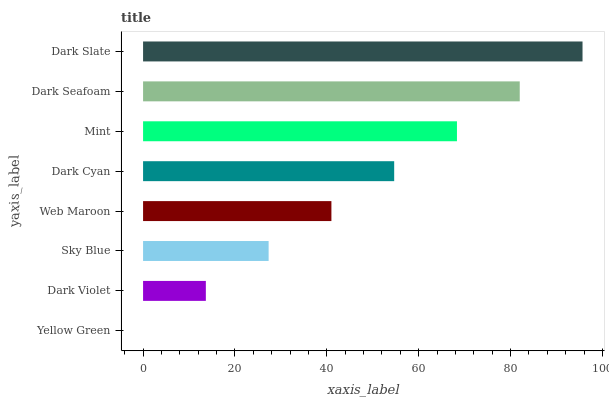Is Yellow Green the minimum?
Answer yes or no. Yes. Is Dark Slate the maximum?
Answer yes or no. Yes. Is Dark Violet the minimum?
Answer yes or no. No. Is Dark Violet the maximum?
Answer yes or no. No. Is Dark Violet greater than Yellow Green?
Answer yes or no. Yes. Is Yellow Green less than Dark Violet?
Answer yes or no. Yes. Is Yellow Green greater than Dark Violet?
Answer yes or no. No. Is Dark Violet less than Yellow Green?
Answer yes or no. No. Is Dark Cyan the high median?
Answer yes or no. Yes. Is Web Maroon the low median?
Answer yes or no. Yes. Is Mint the high median?
Answer yes or no. No. Is Mint the low median?
Answer yes or no. No. 